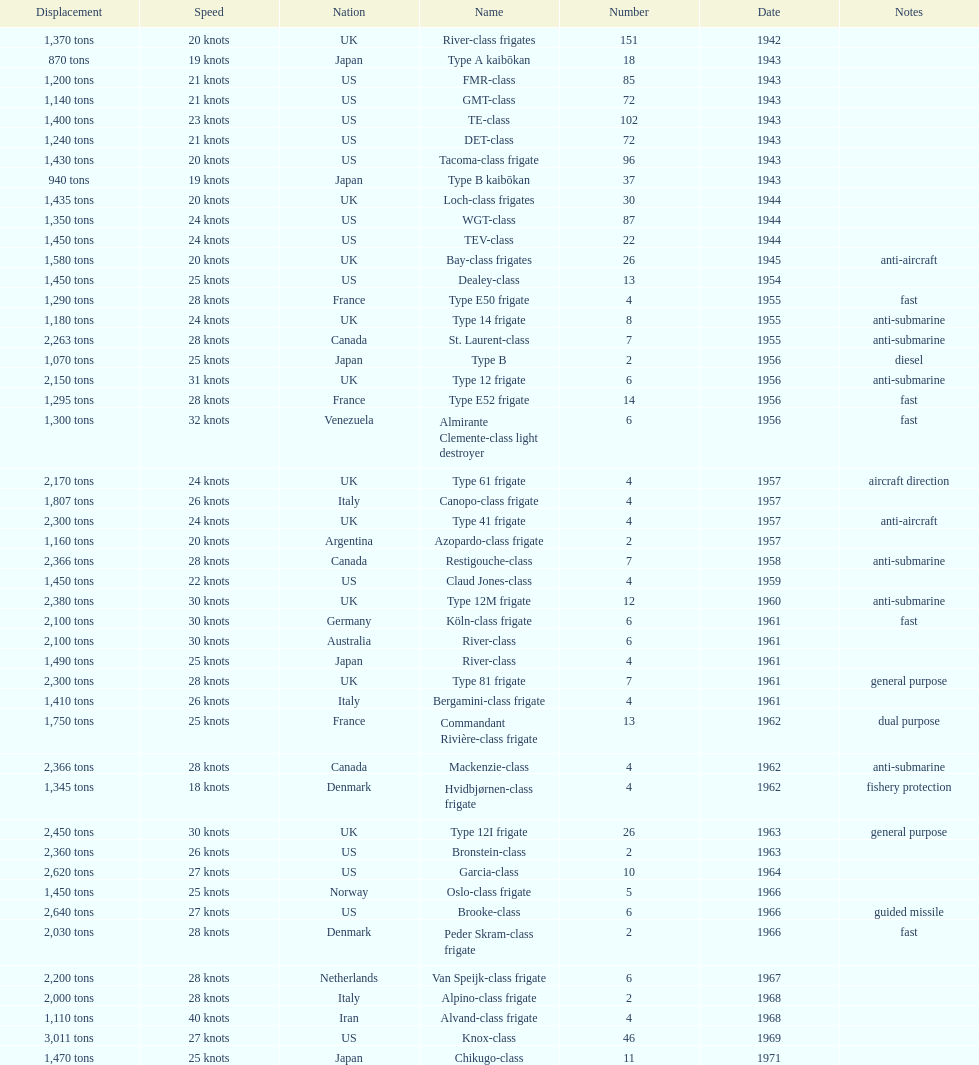How many tons of displacement does type b have? 940 tons. 